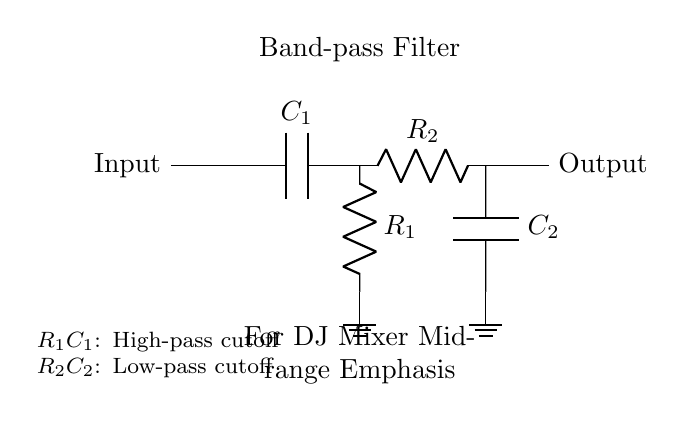What type of filter is shown in the circuit? The circuit is a band-pass filter, as indicated by the label and the structure that includes both high-pass and low-pass filter components.
Answer: band-pass filter What are the components used in the high-pass section? The high-pass section includes a capacitor and a resistor, specifically listed as C1 and R1 in the diagram.
Answer: capacitor and resistor What components form the low-pass filter in this circuit? The low-pass filter consists of a resistor and a capacitor, listed as R2 and C2 in the circuit diagram.
Answer: resistor and capacitor What is the purpose of this filter in the context of a DJ mixer? The filter is designed to isolate mid-range frequencies to emphasize vocals, which is important for enhancing clarity in hip-hop songs.
Answer: emphasize vocals Which components determine the high-pass cutoff frequency? The cutoff frequency for the high-pass filter is determined by the combination of the resistor R1 and capacitor C1, as they set the frequency at which signals start to pass through.
Answer: R1 and C1 How does this filter affect frequencies outside the mid-range? This filter allows mid-range frequencies to pass through while attenuating both low and high frequencies, ensuring that vocals are highlighted in the mix.
Answer: attenuates low and high frequencies 